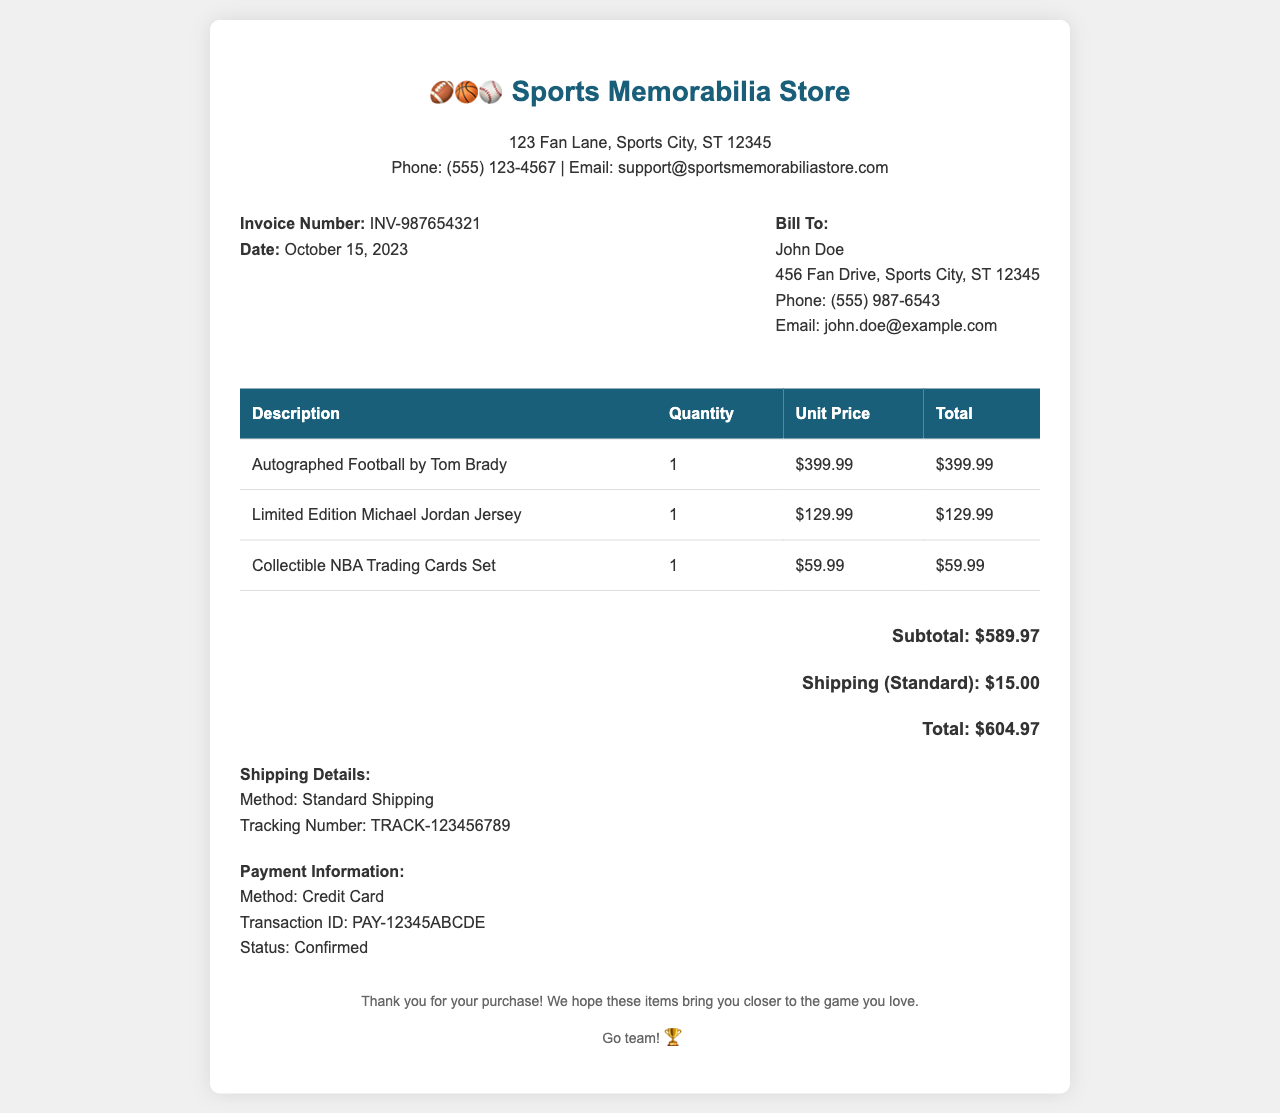What is the invoice number? The invoice number specified in the document is clearly labeled as "Invoice Number".
Answer: INV-987654321 What items were purchased? The items purchased are listed in the table, detailing their descriptions.
Answer: Autographed Football by Tom Brady, Limited Edition Michael Jordan Jersey, Collectible NBA Trading Cards Set What is the total amount due? The total amount is summarized at the end of the invoice as part of the cost breakdown.
Answer: $604.97 What shipping method was used? The shipping details section specifies the chosen shipping method.
Answer: Standard Shipping When was the invoice issued? The date of the invoice appears prominently above the billing information.
Answer: October 15, 2023 What is the payment method confirmed? The payment information section specifies the method of payment used for the purchase.
Answer: Credit Card How much was charged for shipping? Shipping cost is detailed separately in the total cost section of the invoice.
Answer: $15.00 What is the tracking number for the shipment? The tracking number is indicated in the shipping details section.
Answer: TRACK-123456789 What is the subtotal before shipping? The subtotal is provided clearly before adding shipping and total.
Answer: $589.97 